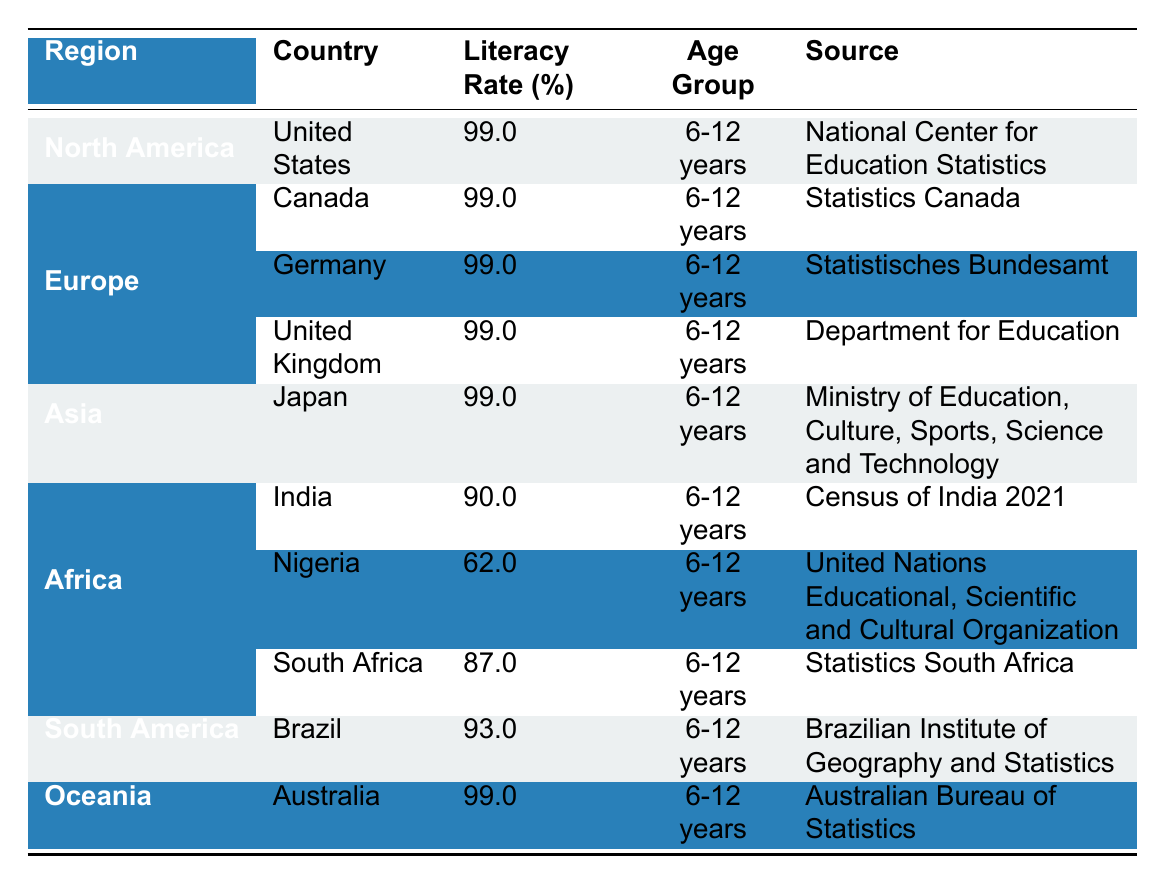What is the literacy rate in India? From the table, India is listed under Asia, and its literacy rate is specified as 90.0% for the age group 6-12 years.
Answer: 90.0% Which country has the lowest literacy rate among the listed countries? The table shows that Nigeria has the lowest literacy rate of 62.0% for the age group 6-12 years, compared to other countries.
Answer: Nigeria Are there any countries in North America with a literacy rate below 99%? The table lists both the United States and Canada as having a literacy rate of 99.0%; there are no countries in North America below this rate.
Answer: No What is the average literacy rate for the countries in Europe? The countries listed in Europe are Germany and the United Kingdom, both with a literacy rate of 99.0%. To find the average: (99.0 + 99.0) / 2 = 99.0.
Answer: 99.0 How does the literacy rate in South Africa compare to that in India? South Africa has a literacy rate of 87.0%, while India has a literacy rate of 90.0%. To compare: 90.0 (India) is greater than 87.0 (South Africa).
Answer: India has a higher literacy rate What is the total literacy rate of all the countries listed in Africa? The African countries listed are Nigeria (62.0%) and South Africa (87.0%). To find the total, add: 62.0 + 87.0 = 149.0.
Answer: 149.0 Is Australia's literacy rate higher than Brazil's? The table shows Australia's literacy rate as 99.0% and Brazil's as 93.0%. Since 99.0% is greater than 93.0%, Australia has a higher literacy rate.
Answer: Yes If we consider only countries from Asia, what is the difference between the literacy rates of Japan and India? Japan has a literacy rate of 99.0%, while India's rate is 90.0%. To find the difference, subtract: 99.0 - 90.0 = 9.0.
Answer: 9.0 